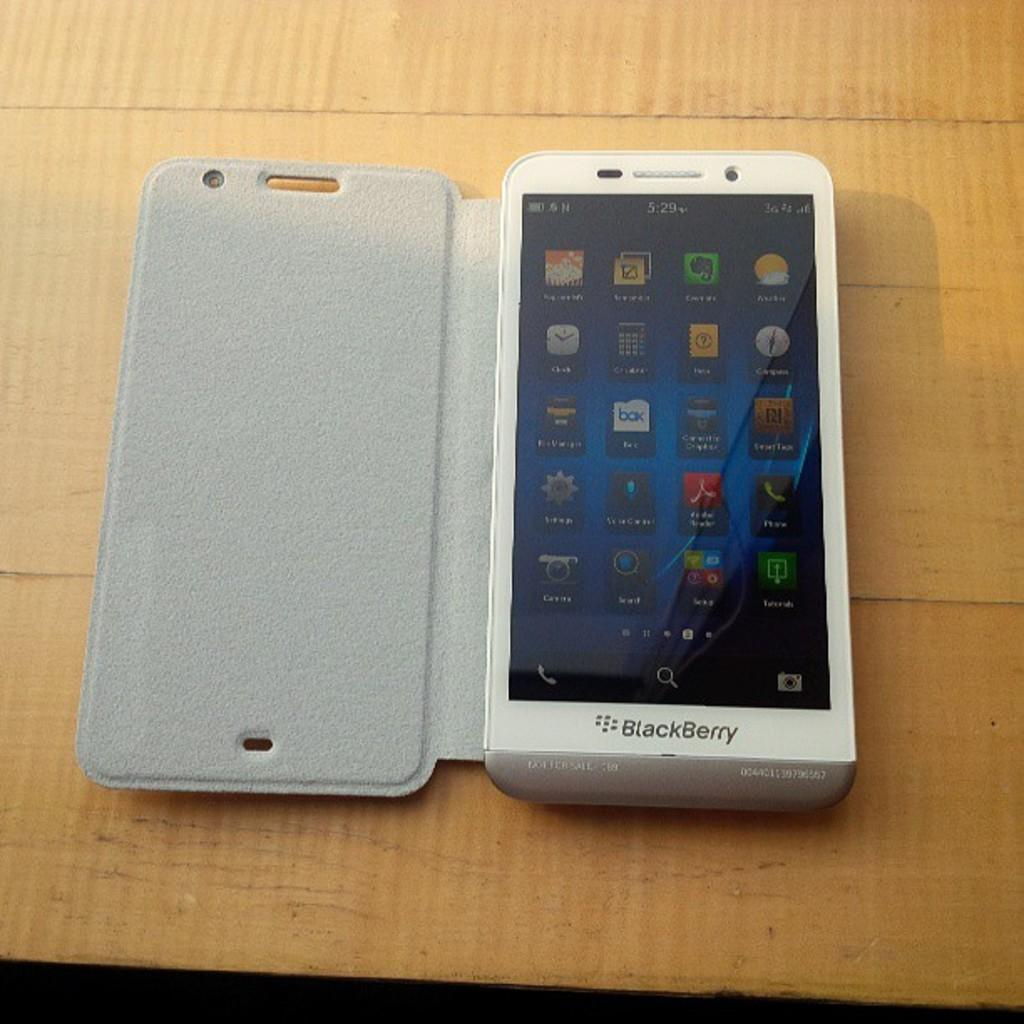<image>
Describe the image concisely. A white Blackberry with the screen showing in a grey case. 